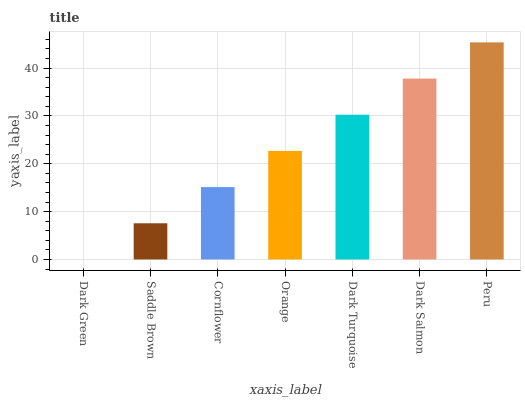Is Dark Green the minimum?
Answer yes or no. Yes. Is Peru the maximum?
Answer yes or no. Yes. Is Saddle Brown the minimum?
Answer yes or no. No. Is Saddle Brown the maximum?
Answer yes or no. No. Is Saddle Brown greater than Dark Green?
Answer yes or no. Yes. Is Dark Green less than Saddle Brown?
Answer yes or no. Yes. Is Dark Green greater than Saddle Brown?
Answer yes or no. No. Is Saddle Brown less than Dark Green?
Answer yes or no. No. Is Orange the high median?
Answer yes or no. Yes. Is Orange the low median?
Answer yes or no. Yes. Is Cornflower the high median?
Answer yes or no. No. Is Dark Salmon the low median?
Answer yes or no. No. 